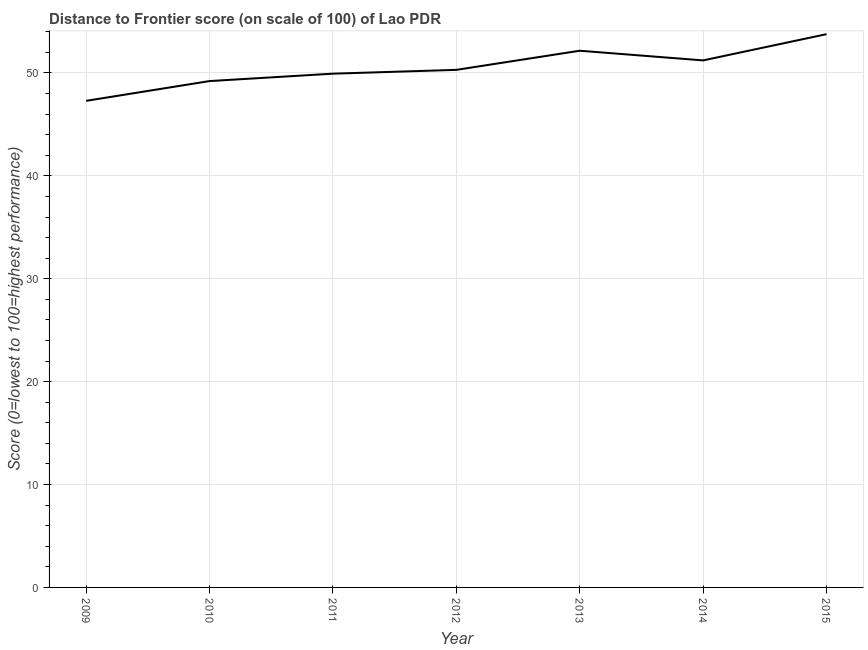What is the distance to frontier score in 2013?
Your answer should be compact. 52.16. Across all years, what is the maximum distance to frontier score?
Keep it short and to the point. 53.77. Across all years, what is the minimum distance to frontier score?
Your answer should be compact. 47.29. In which year was the distance to frontier score maximum?
Your answer should be very brief. 2015. What is the sum of the distance to frontier score?
Keep it short and to the point. 353.88. What is the difference between the distance to frontier score in 2012 and 2013?
Give a very brief answer. -1.86. What is the average distance to frontier score per year?
Offer a terse response. 50.55. What is the median distance to frontier score?
Provide a short and direct response. 50.3. In how many years, is the distance to frontier score greater than 4 ?
Offer a very short reply. 7. What is the ratio of the distance to frontier score in 2012 to that in 2013?
Give a very brief answer. 0.96. Is the difference between the distance to frontier score in 2010 and 2012 greater than the difference between any two years?
Ensure brevity in your answer.  No. What is the difference between the highest and the second highest distance to frontier score?
Give a very brief answer. 1.61. What is the difference between the highest and the lowest distance to frontier score?
Your answer should be compact. 6.48. How many years are there in the graph?
Your response must be concise. 7. Are the values on the major ticks of Y-axis written in scientific E-notation?
Ensure brevity in your answer.  No. Does the graph contain any zero values?
Your answer should be very brief. No. What is the title of the graph?
Keep it short and to the point. Distance to Frontier score (on scale of 100) of Lao PDR. What is the label or title of the X-axis?
Provide a short and direct response. Year. What is the label or title of the Y-axis?
Your response must be concise. Score (0=lowest to 100=highest performance). What is the Score (0=lowest to 100=highest performance) of 2009?
Provide a short and direct response. 47.29. What is the Score (0=lowest to 100=highest performance) of 2010?
Provide a short and direct response. 49.21. What is the Score (0=lowest to 100=highest performance) in 2011?
Provide a short and direct response. 49.93. What is the Score (0=lowest to 100=highest performance) of 2012?
Offer a terse response. 50.3. What is the Score (0=lowest to 100=highest performance) of 2013?
Offer a terse response. 52.16. What is the Score (0=lowest to 100=highest performance) of 2014?
Your response must be concise. 51.22. What is the Score (0=lowest to 100=highest performance) in 2015?
Provide a succinct answer. 53.77. What is the difference between the Score (0=lowest to 100=highest performance) in 2009 and 2010?
Your response must be concise. -1.92. What is the difference between the Score (0=lowest to 100=highest performance) in 2009 and 2011?
Your response must be concise. -2.64. What is the difference between the Score (0=lowest to 100=highest performance) in 2009 and 2012?
Make the answer very short. -3.01. What is the difference between the Score (0=lowest to 100=highest performance) in 2009 and 2013?
Keep it short and to the point. -4.87. What is the difference between the Score (0=lowest to 100=highest performance) in 2009 and 2014?
Ensure brevity in your answer.  -3.93. What is the difference between the Score (0=lowest to 100=highest performance) in 2009 and 2015?
Your response must be concise. -6.48. What is the difference between the Score (0=lowest to 100=highest performance) in 2010 and 2011?
Your answer should be compact. -0.72. What is the difference between the Score (0=lowest to 100=highest performance) in 2010 and 2012?
Ensure brevity in your answer.  -1.09. What is the difference between the Score (0=lowest to 100=highest performance) in 2010 and 2013?
Offer a terse response. -2.95. What is the difference between the Score (0=lowest to 100=highest performance) in 2010 and 2014?
Ensure brevity in your answer.  -2.01. What is the difference between the Score (0=lowest to 100=highest performance) in 2010 and 2015?
Offer a very short reply. -4.56. What is the difference between the Score (0=lowest to 100=highest performance) in 2011 and 2012?
Provide a succinct answer. -0.37. What is the difference between the Score (0=lowest to 100=highest performance) in 2011 and 2013?
Offer a very short reply. -2.23. What is the difference between the Score (0=lowest to 100=highest performance) in 2011 and 2014?
Your answer should be compact. -1.29. What is the difference between the Score (0=lowest to 100=highest performance) in 2011 and 2015?
Your answer should be compact. -3.84. What is the difference between the Score (0=lowest to 100=highest performance) in 2012 and 2013?
Provide a short and direct response. -1.86. What is the difference between the Score (0=lowest to 100=highest performance) in 2012 and 2014?
Ensure brevity in your answer.  -0.92. What is the difference between the Score (0=lowest to 100=highest performance) in 2012 and 2015?
Provide a short and direct response. -3.47. What is the difference between the Score (0=lowest to 100=highest performance) in 2013 and 2015?
Offer a very short reply. -1.61. What is the difference between the Score (0=lowest to 100=highest performance) in 2014 and 2015?
Keep it short and to the point. -2.55. What is the ratio of the Score (0=lowest to 100=highest performance) in 2009 to that in 2011?
Provide a succinct answer. 0.95. What is the ratio of the Score (0=lowest to 100=highest performance) in 2009 to that in 2013?
Give a very brief answer. 0.91. What is the ratio of the Score (0=lowest to 100=highest performance) in 2009 to that in 2014?
Ensure brevity in your answer.  0.92. What is the ratio of the Score (0=lowest to 100=highest performance) in 2009 to that in 2015?
Ensure brevity in your answer.  0.88. What is the ratio of the Score (0=lowest to 100=highest performance) in 2010 to that in 2012?
Your answer should be compact. 0.98. What is the ratio of the Score (0=lowest to 100=highest performance) in 2010 to that in 2013?
Keep it short and to the point. 0.94. What is the ratio of the Score (0=lowest to 100=highest performance) in 2010 to that in 2015?
Ensure brevity in your answer.  0.92. What is the ratio of the Score (0=lowest to 100=highest performance) in 2011 to that in 2014?
Ensure brevity in your answer.  0.97. What is the ratio of the Score (0=lowest to 100=highest performance) in 2011 to that in 2015?
Make the answer very short. 0.93. What is the ratio of the Score (0=lowest to 100=highest performance) in 2012 to that in 2014?
Make the answer very short. 0.98. What is the ratio of the Score (0=lowest to 100=highest performance) in 2012 to that in 2015?
Offer a very short reply. 0.94. What is the ratio of the Score (0=lowest to 100=highest performance) in 2013 to that in 2014?
Provide a short and direct response. 1.02. What is the ratio of the Score (0=lowest to 100=highest performance) in 2014 to that in 2015?
Keep it short and to the point. 0.95. 